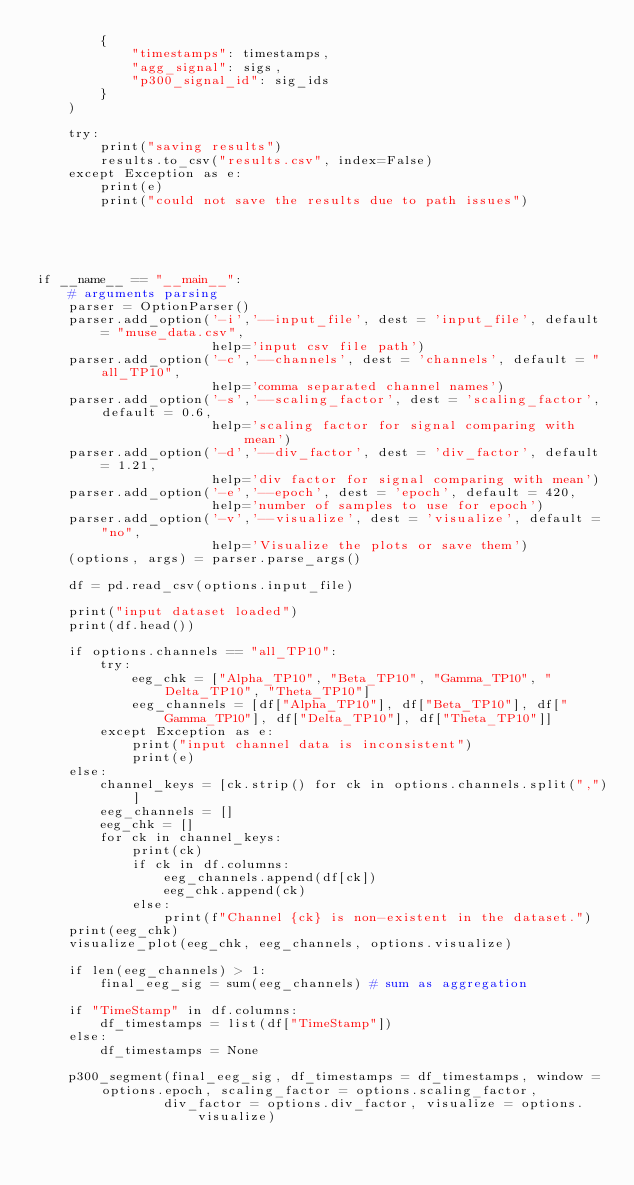<code> <loc_0><loc_0><loc_500><loc_500><_Python_>        {
            "timestamps": timestamps,
            "agg_signal": sigs,
            "p300_signal_id": sig_ids
        }
    )

    try:
        print("saving results")
        results.to_csv("results.csv", index=False)
    except Exception as e:
        print(e)
        print("could not save the results due to path issues")

    



if __name__ == "__main__":
    # arguments parsing
    parser = OptionParser()
    parser.add_option('-i','--input_file', dest = 'input_file', default = "muse_data.csv",
                      help='input csv file path')
    parser.add_option('-c','--channels', dest = 'channels', default = "all_TP10",
                      help='comma separated channel names')
    parser.add_option('-s','--scaling_factor', dest = 'scaling_factor', default = 0.6,
                      help='scaling factor for signal comparing with mean')
    parser.add_option('-d','--div_factor', dest = 'div_factor', default = 1.21,
                      help='div factor for signal comparing with mean')
    parser.add_option('-e','--epoch', dest = 'epoch', default = 420,
                      help='number of samples to use for epoch')           
    parser.add_option('-v','--visualize', dest = 'visualize', default = "no",
                      help='Visualize the plots or save them')
    (options, args) = parser.parse_args()

    df = pd.read_csv(options.input_file)
    
    print("input dataset loaded")
    print(df.head())

    if options.channels == "all_TP10":
        try:
            eeg_chk = ["Alpha_TP10", "Beta_TP10", "Gamma_TP10", "Delta_TP10", "Theta_TP10"]
            eeg_channels = [df["Alpha_TP10"], df["Beta_TP10"], df["Gamma_TP10"], df["Delta_TP10"], df["Theta_TP10"]]
        except Exception as e:
            print("input channel data is inconsistent")
            print(e)
    else:
        channel_keys = [ck.strip() for ck in options.channels.split(",")]
        eeg_channels = []
        eeg_chk = []
        for ck in channel_keys:
            print(ck)
            if ck in df.columns:
                eeg_channels.append(df[ck])
                eeg_chk.append(ck)
            else:
                print(f"Channel {ck} is non-existent in the dataset.")
    print(eeg_chk)
    visualize_plot(eeg_chk, eeg_channels, options.visualize)

    if len(eeg_channels) > 1:
        final_eeg_sig = sum(eeg_channels) # sum as aggregation

    if "TimeStamp" in df.columns:
        df_timestamps = list(df["TimeStamp"])
    else:
        df_timestamps = None

    p300_segment(final_eeg_sig, df_timestamps = df_timestamps, window = options.epoch, scaling_factor = options.scaling_factor, 
                div_factor = options.div_factor, visualize = options.visualize)</code> 